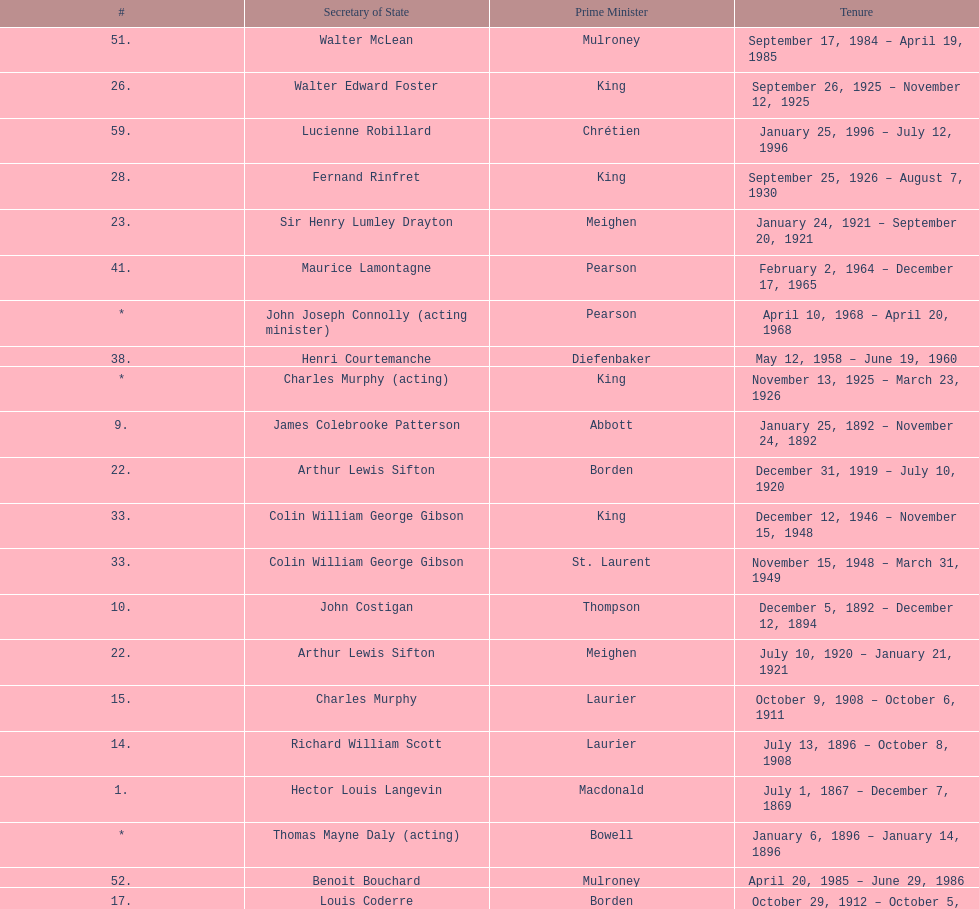How many secretary of states were under prime minister macdonald? 6. 